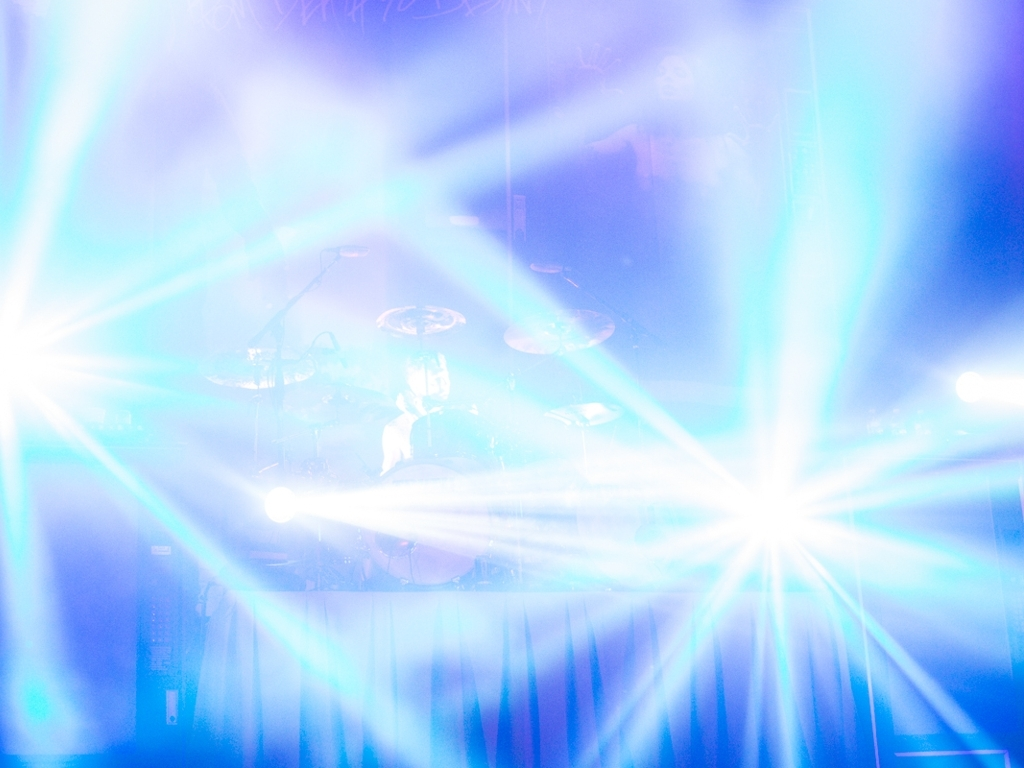If you had to guess, what genre of music could be played during this event? Considering the visually stimulating light display, which is commonly used in rock or electronic music concerts to enhance the energetic experience, one could infer that the event might be related to those genres. However, without more contextual details, it's difficult to determine the exact genre with certainty. 